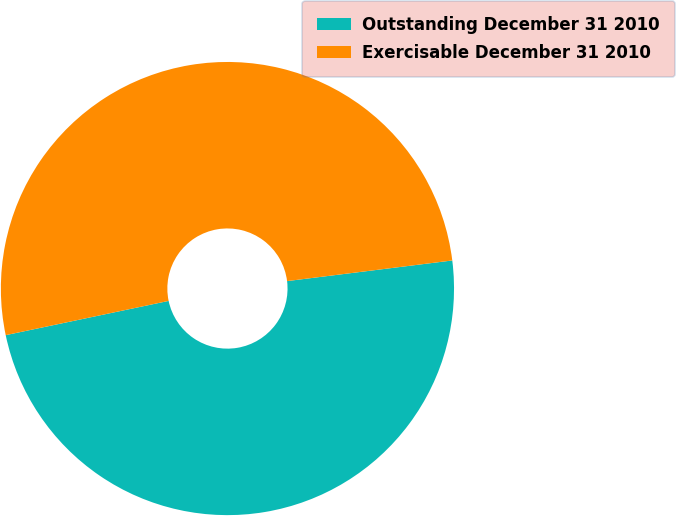Convert chart to OTSL. <chart><loc_0><loc_0><loc_500><loc_500><pie_chart><fcel>Outstanding December 31 2010<fcel>Exercisable December 31 2010<nl><fcel>48.68%<fcel>51.32%<nl></chart> 